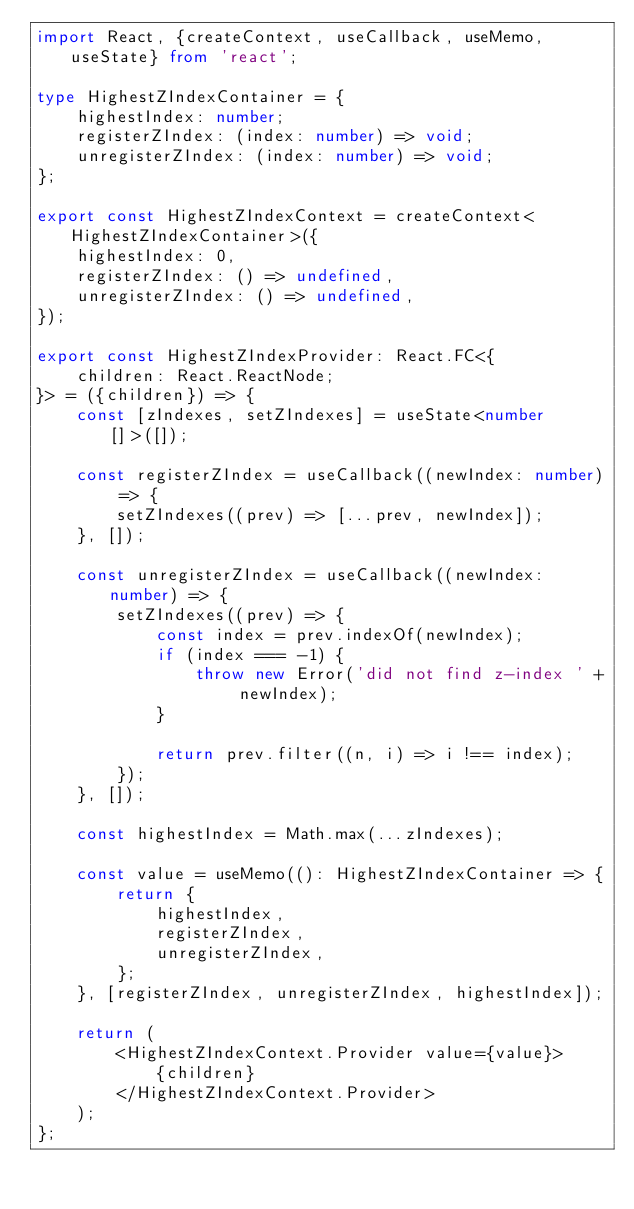Convert code to text. <code><loc_0><loc_0><loc_500><loc_500><_TypeScript_>import React, {createContext, useCallback, useMemo, useState} from 'react';

type HighestZIndexContainer = {
	highestIndex: number;
	registerZIndex: (index: number) => void;
	unregisterZIndex: (index: number) => void;
};

export const HighestZIndexContext = createContext<HighestZIndexContainer>({
	highestIndex: 0,
	registerZIndex: () => undefined,
	unregisterZIndex: () => undefined,
});

export const HighestZIndexProvider: React.FC<{
	children: React.ReactNode;
}> = ({children}) => {
	const [zIndexes, setZIndexes] = useState<number[]>([]);

	const registerZIndex = useCallback((newIndex: number) => {
		setZIndexes((prev) => [...prev, newIndex]);
	}, []);

	const unregisterZIndex = useCallback((newIndex: number) => {
		setZIndexes((prev) => {
			const index = prev.indexOf(newIndex);
			if (index === -1) {
				throw new Error('did not find z-index ' + newIndex);
			}

			return prev.filter((n, i) => i !== index);
		});
	}, []);

	const highestIndex = Math.max(...zIndexes);

	const value = useMemo((): HighestZIndexContainer => {
		return {
			highestIndex,
			registerZIndex,
			unregisterZIndex,
		};
	}, [registerZIndex, unregisterZIndex, highestIndex]);

	return (
		<HighestZIndexContext.Provider value={value}>
			{children}
		</HighestZIndexContext.Provider>
	);
};
</code> 